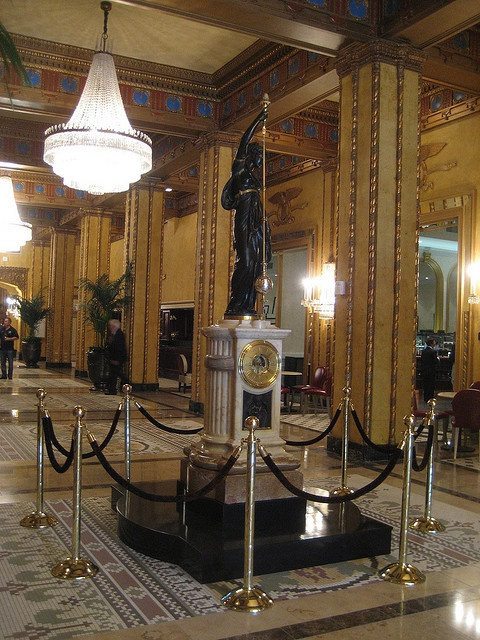Describe the objects in this image and their specific colors. I can see potted plant in gray, black, and olive tones, clock in gray, olive, and tan tones, potted plant in gray, black, and olive tones, chair in gray, black, and olive tones, and people in gray, black, and maroon tones in this image. 